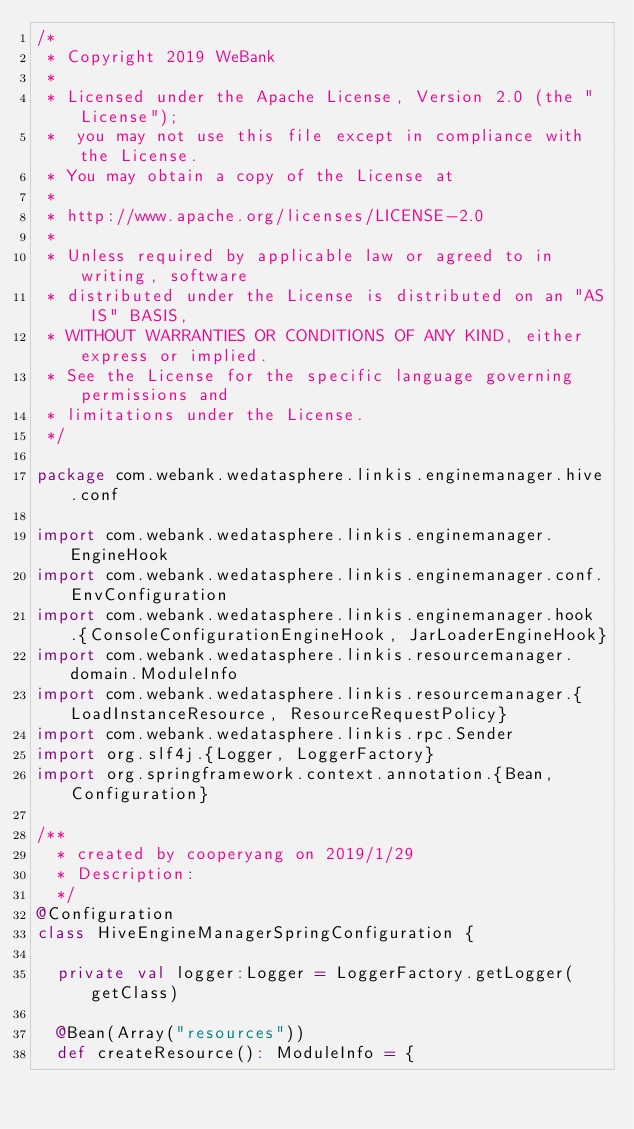<code> <loc_0><loc_0><loc_500><loc_500><_Scala_>/*
 * Copyright 2019 WeBank
 *
 * Licensed under the Apache License, Version 2.0 (the "License");
 *  you may not use this file except in compliance with the License.
 * You may obtain a copy of the License at
 *
 * http://www.apache.org/licenses/LICENSE-2.0
 *
 * Unless required by applicable law or agreed to in writing, software
 * distributed under the License is distributed on an "AS IS" BASIS,
 * WITHOUT WARRANTIES OR CONDITIONS OF ANY KIND, either express or implied.
 * See the License for the specific language governing permissions and
 * limitations under the License.
 */

package com.webank.wedatasphere.linkis.enginemanager.hive.conf

import com.webank.wedatasphere.linkis.enginemanager.EngineHook
import com.webank.wedatasphere.linkis.enginemanager.conf.EnvConfiguration
import com.webank.wedatasphere.linkis.enginemanager.hook.{ConsoleConfigurationEngineHook, JarLoaderEngineHook}
import com.webank.wedatasphere.linkis.resourcemanager.domain.ModuleInfo
import com.webank.wedatasphere.linkis.resourcemanager.{LoadInstanceResource, ResourceRequestPolicy}
import com.webank.wedatasphere.linkis.rpc.Sender
import org.slf4j.{Logger, LoggerFactory}
import org.springframework.context.annotation.{Bean, Configuration}

/**
  * created by cooperyang on 2019/1/29
  * Description:
  */
@Configuration
class HiveEngineManagerSpringConfiguration {

  private val logger:Logger = LoggerFactory.getLogger(getClass)

  @Bean(Array("resources"))
  def createResource(): ModuleInfo = {</code> 